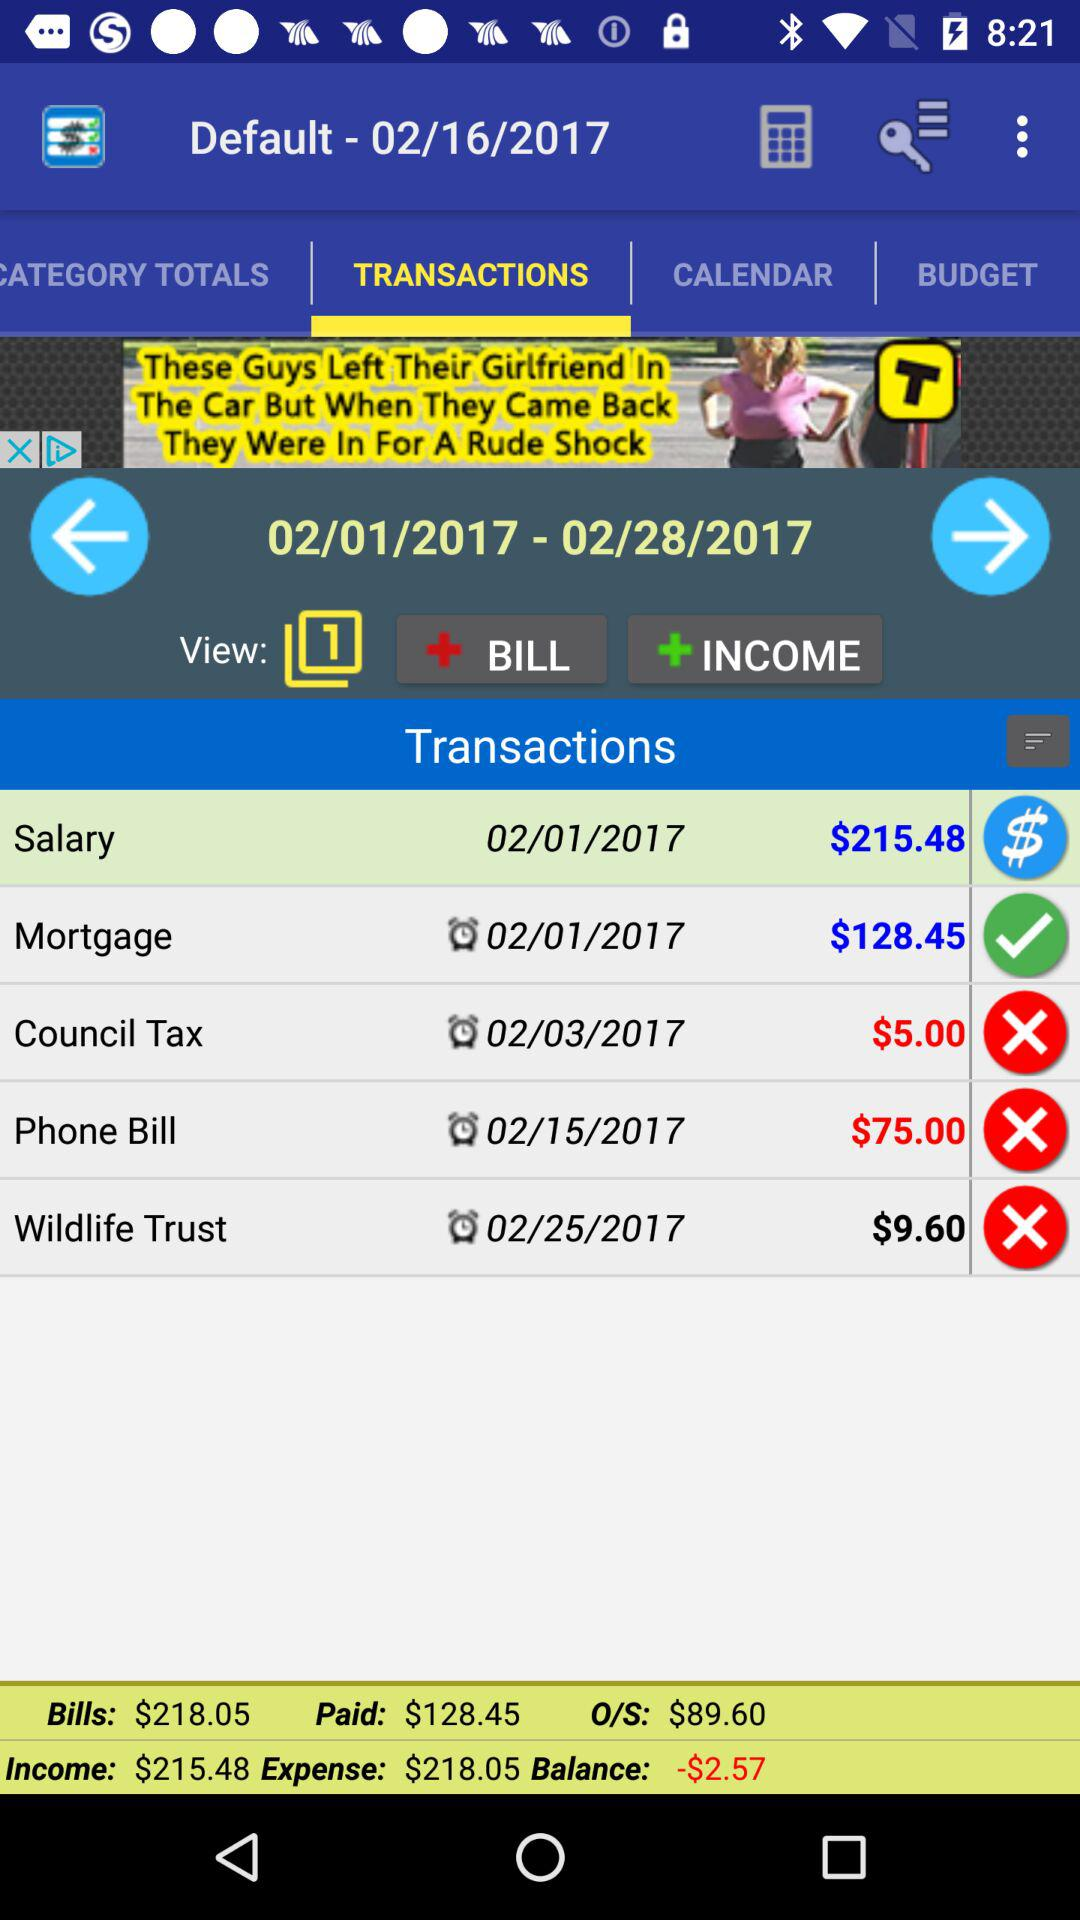What is the amount of the council tax? The amount of the council tax is $5. 